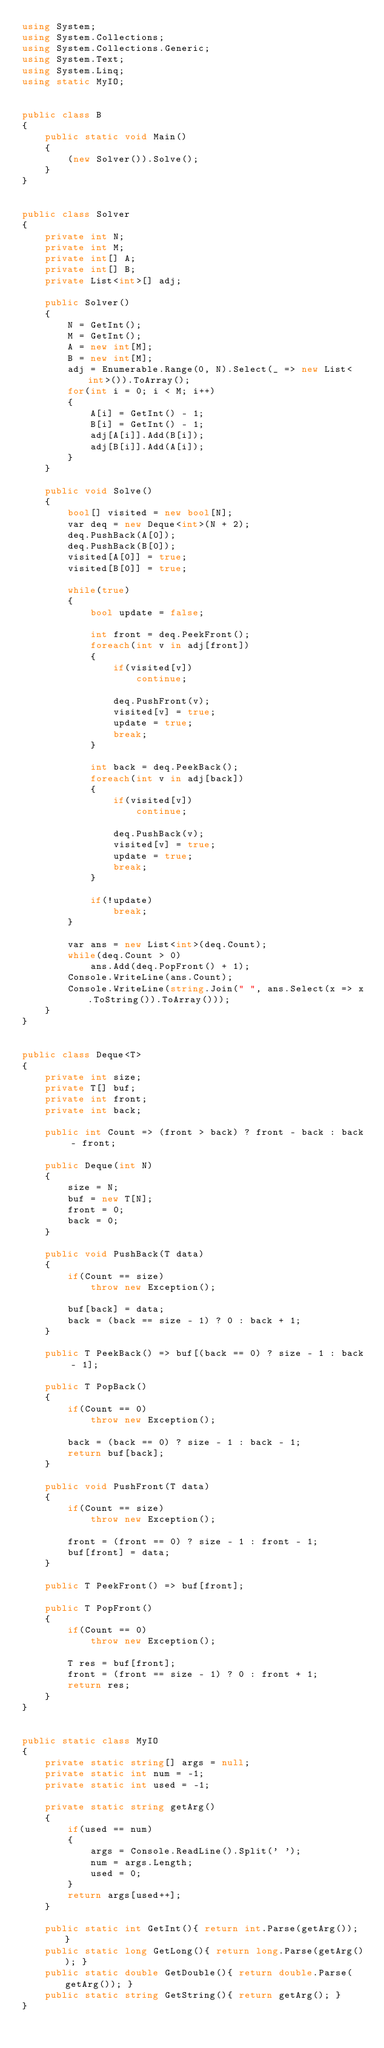<code> <loc_0><loc_0><loc_500><loc_500><_C#_>using System;
using System.Collections;
using System.Collections.Generic;
using System.Text;
using System.Linq;
using static MyIO;


public class B
{
	public static void Main()
	{
		(new Solver()).Solve();
	}
}


public class Solver
{
	private int N;
	private int M;
	private int[] A;
	private int[] B;
	private List<int>[] adj;

	public Solver()
	{
		N = GetInt();
		M = GetInt();
		A = new int[M];
		B = new int[M];
		adj = Enumerable.Range(0, N).Select(_ => new List<int>()).ToArray();
		for(int i = 0; i < M; i++)
		{
			A[i] = GetInt() - 1;
			B[i] = GetInt() - 1;
			adj[A[i]].Add(B[i]);
			adj[B[i]].Add(A[i]);
		}
	}

	public void Solve()
	{
		bool[] visited = new bool[N];
		var deq = new Deque<int>(N + 2);
		deq.PushBack(A[0]);
		deq.PushBack(B[0]);
		visited[A[0]] = true;
		visited[B[0]] = true;

		while(true)
		{
			bool update = false;

			int front = deq.PeekFront();
			foreach(int v in adj[front])
			{
				if(visited[v])
					continue;

				deq.PushFront(v);
				visited[v] = true;
				update = true;
				break;
			}

			int back = deq.PeekBack();
			foreach(int v in adj[back])
			{
				if(visited[v])
					continue;

				deq.PushBack(v);
				visited[v] = true;
				update = true;
				break;
			}

			if(!update)
				break;
		}

		var ans = new List<int>(deq.Count);
		while(deq.Count > 0)
			ans.Add(deq.PopFront() + 1);
		Console.WriteLine(ans.Count);
		Console.WriteLine(string.Join(" ", ans.Select(x => x.ToString()).ToArray()));
	}
}


public class Deque<T>
{
	private int size;
	private T[] buf;
	private int front;
	private int back;

	public int Count => (front > back) ? front - back : back - front;

	public Deque(int N)
	{
		size = N;
		buf = new T[N];
		front = 0;
		back = 0;
	}

	public void PushBack(T data)
	{
		if(Count == size)
			throw new Exception();

		buf[back] = data;
		back = (back == size - 1) ? 0 : back + 1;
	}

	public T PeekBack() => buf[(back == 0) ? size - 1 : back - 1];

	public T PopBack()
	{
		if(Count == 0)
			throw new Exception();

		back = (back == 0) ? size - 1 : back - 1;
		return buf[back];
	}
	
	public void PushFront(T data)
	{
		if(Count == size)
			throw new Exception();

		front = (front == 0) ? size - 1 : front - 1;
		buf[front] = data;
	}

	public T PeekFront() => buf[front];

	public T PopFront()
	{
		if(Count == 0)
			throw new Exception();

		T res = buf[front];
		front = (front == size - 1) ? 0 : front + 1;
		return res;
	}
}


public static class MyIO
{
	private static string[] args = null;
	private static int num = -1;
	private static int used = -1;

	private static string getArg()
	{
		if(used == num)
		{
			args = Console.ReadLine().Split(' ');
			num = args.Length;
			used = 0;
		}
		return args[used++];
	}

	public static int GetInt(){ return int.Parse(getArg()); }
	public static long GetLong(){ return long.Parse(getArg()); }
	public static double GetDouble(){ return double.Parse(getArg()); }
	public static string GetString(){ return getArg(); }
}
</code> 